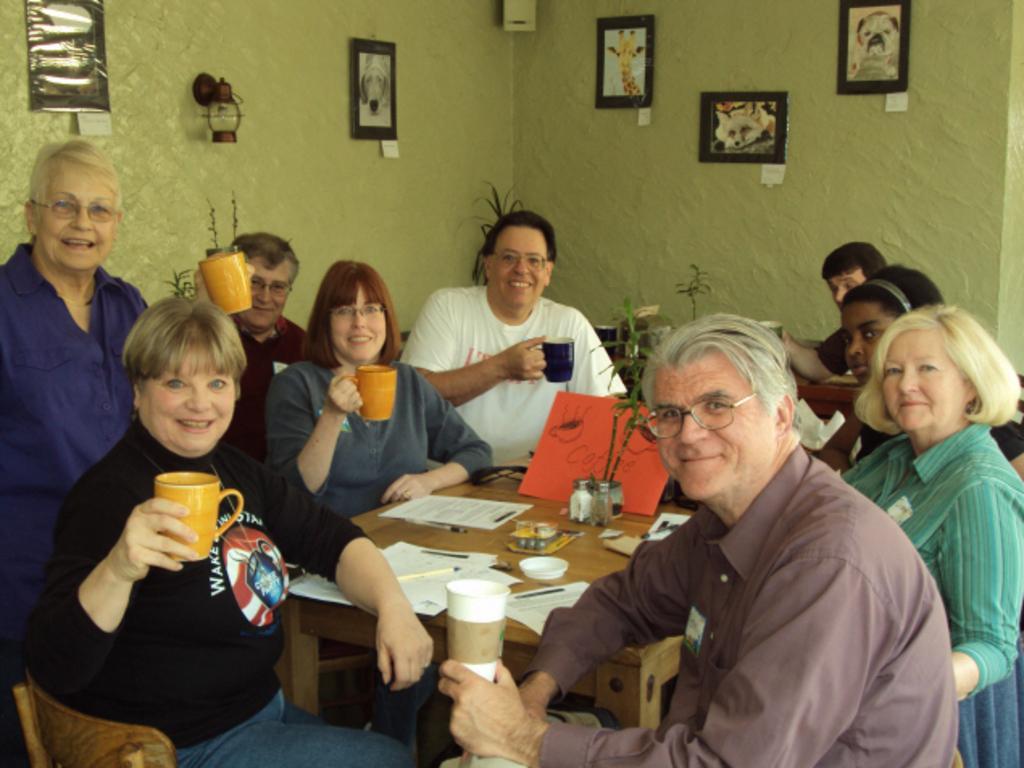In one or two sentences, can you explain what this image depicts? Here we can see a group of people sitting on chairs with a table in front of them and each and everybody has cups in their hand and everybody is smiling and there are portraits of animals behind the wall present 